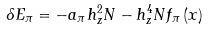<formula> <loc_0><loc_0><loc_500><loc_500>\delta E _ { \pi } = - a _ { \pi } h _ { z } ^ { 2 } N - h _ { z } ^ { 4 } N f _ { \pi } \left ( x \right )</formula> 